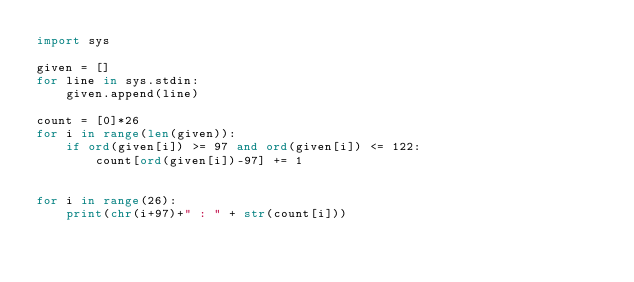<code> <loc_0><loc_0><loc_500><loc_500><_Python_>import sys

given = []
for line in sys.stdin:
    given.append(line)

count = [0]*26
for i in range(len(given)):
    if ord(given[i]) >= 97 and ord(given[i]) <= 122:
        count[ord(given[i])-97] += 1


for i in range(26):
    print(chr(i+97)+" : " + str(count[i]))</code> 